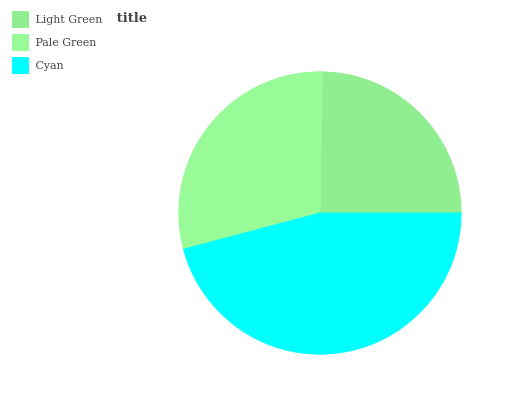Is Light Green the minimum?
Answer yes or no. Yes. Is Cyan the maximum?
Answer yes or no. Yes. Is Pale Green the minimum?
Answer yes or no. No. Is Pale Green the maximum?
Answer yes or no. No. Is Pale Green greater than Light Green?
Answer yes or no. Yes. Is Light Green less than Pale Green?
Answer yes or no. Yes. Is Light Green greater than Pale Green?
Answer yes or no. No. Is Pale Green less than Light Green?
Answer yes or no. No. Is Pale Green the high median?
Answer yes or no. Yes. Is Pale Green the low median?
Answer yes or no. Yes. Is Light Green the high median?
Answer yes or no. No. Is Cyan the low median?
Answer yes or no. No. 